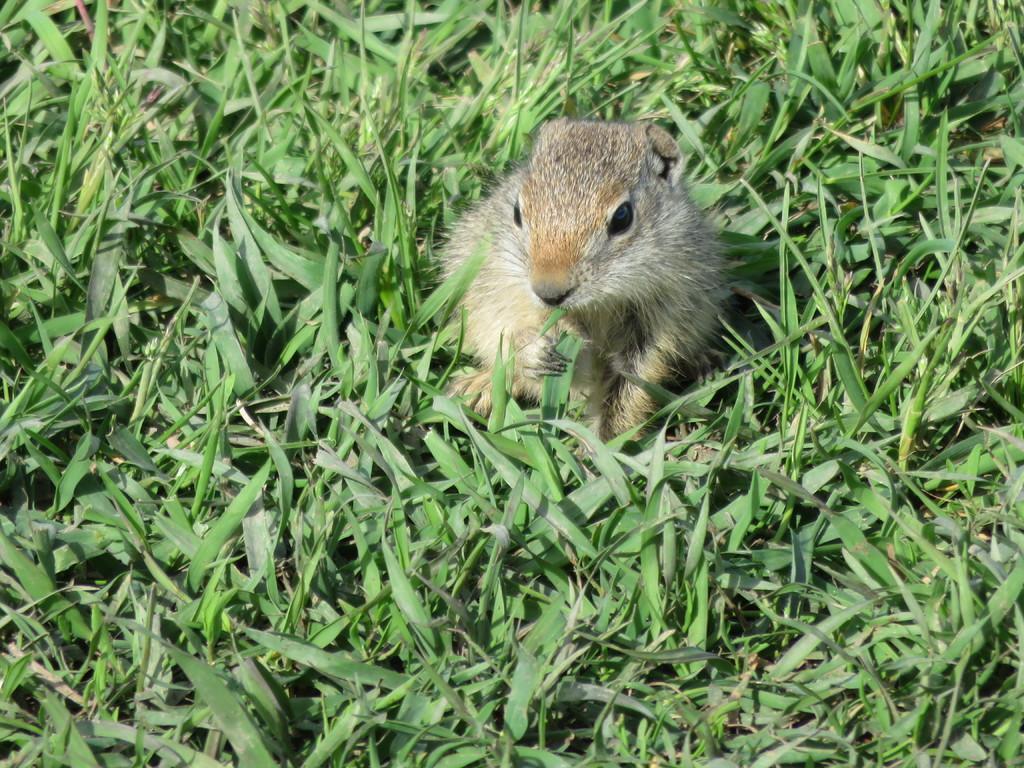Could you give a brief overview of what you see in this image? This picture is mainly highlighted with a squirrel and it is holding a green leaf. In this picture we can see the plants. 